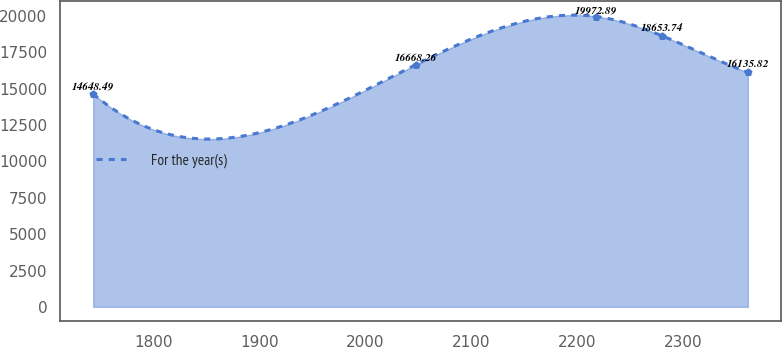Convert chart to OTSL. <chart><loc_0><loc_0><loc_500><loc_500><line_chart><ecel><fcel>For the year(s)<nl><fcel>1742.98<fcel>14648.5<nl><fcel>2048.09<fcel>16668.3<nl><fcel>2218.42<fcel>19972.9<nl><fcel>2280.28<fcel>18653.7<nl><fcel>2361.54<fcel>16135.8<nl></chart> 